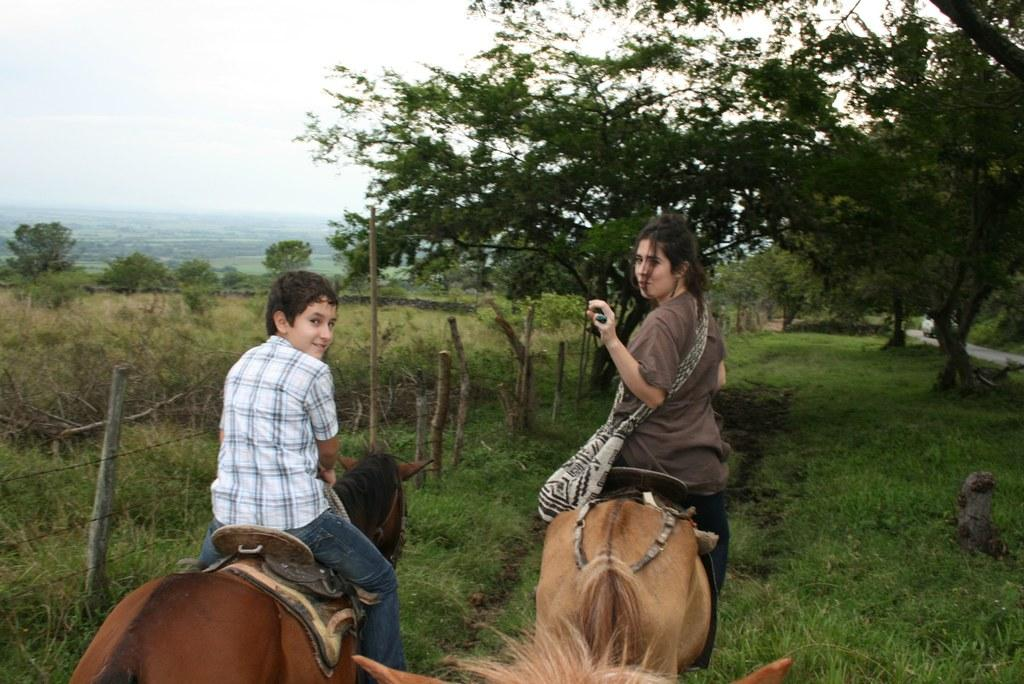Where is the location of the image? The image is outside of the city. Who are the people in the image? There are two people in the image: a woman and a boy. What are the woman and the boy doing in the image? They are sitting on a horse and riding it. What can be seen in the background of the image? There are trees in the background of the image. What is visible at the top of the image? The sky is visible at the top of the image. What type of milk is being produced by the twist in the image? There is no twist or milk present in the image; it features a woman and a boy riding a horse outside the city. 